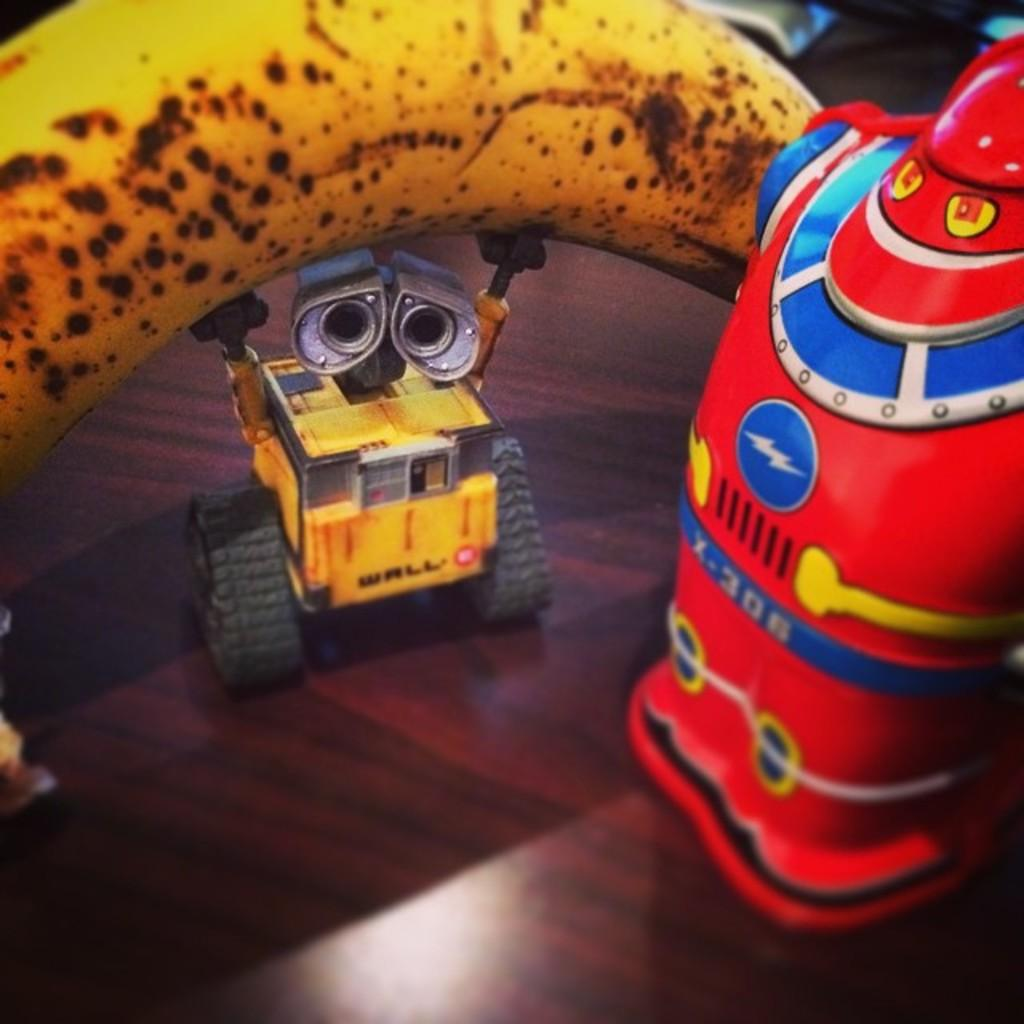What objects are present in the image? There are toys in the image. What is the material of the surface on which the toys are placed? The surface is made of wood. Are there any fruits visible in the image? Yes, there is a ripe banana in the image. What time of day is it in the image, given the presence of a cherry? There is no cherry present in the image, so we cannot determine the time of day based on that information. 